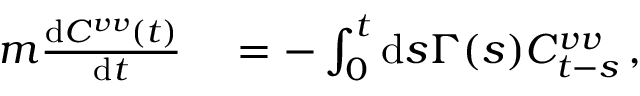<formula> <loc_0><loc_0><loc_500><loc_500>\begin{array} { r l } { m \frac { d C ^ { v v } ( t ) } { d t } } & = - \int _ { 0 } ^ { t } d s \Gamma ( s ) C _ { t - s } ^ { v v } \, , } \end{array}</formula> 